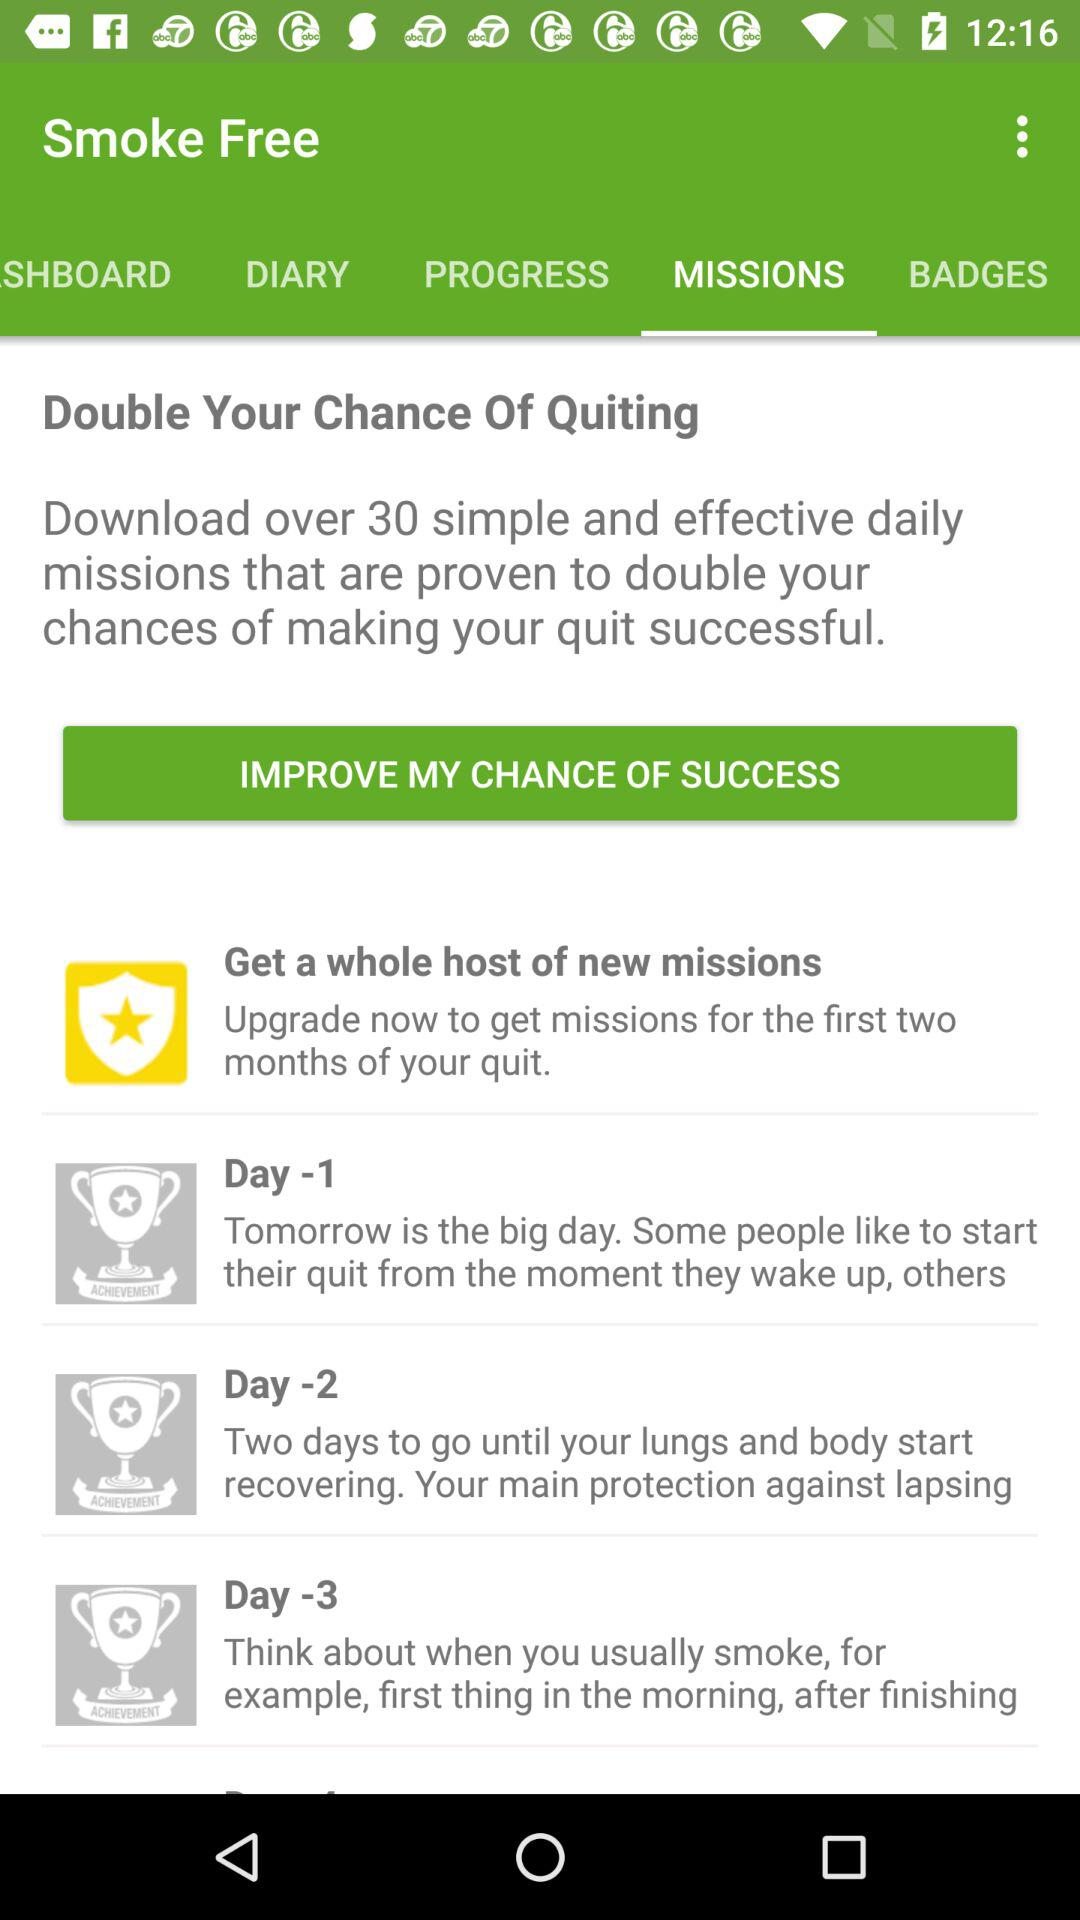How long is the mission? The missions are on a daily basis. 